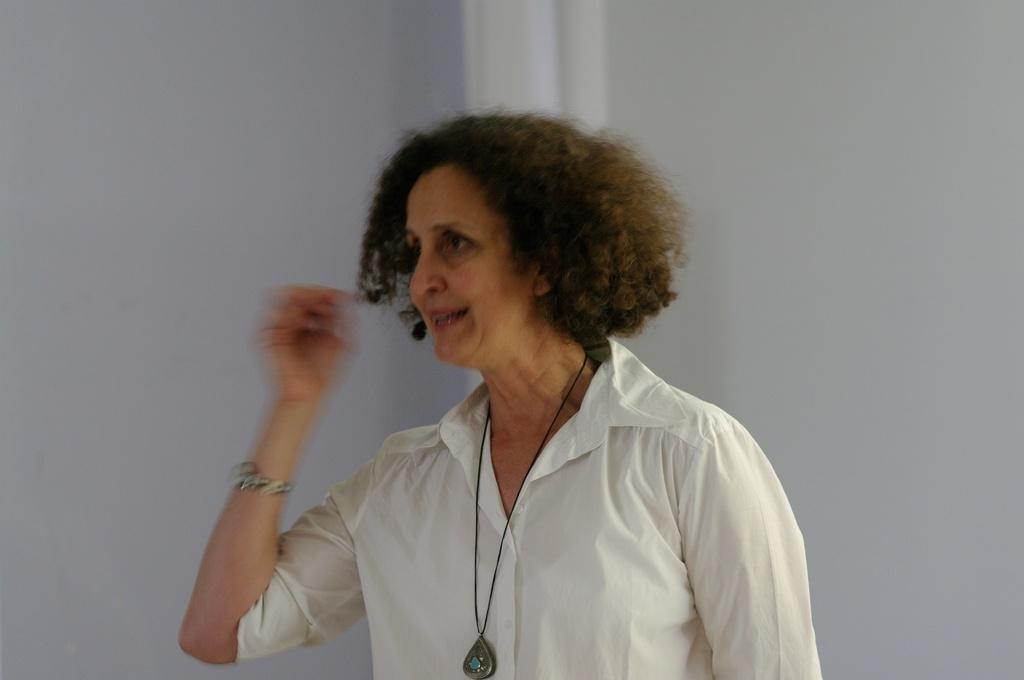What is the main subject of the image? The main subject of the image is a woman. What is the woman wearing in the image? The woman is wearing a white dress in the image. What type of quill is the woman holding in the image? There is no quill present in the image. How many hens can be seen in the image? There are no hens present in the image. 